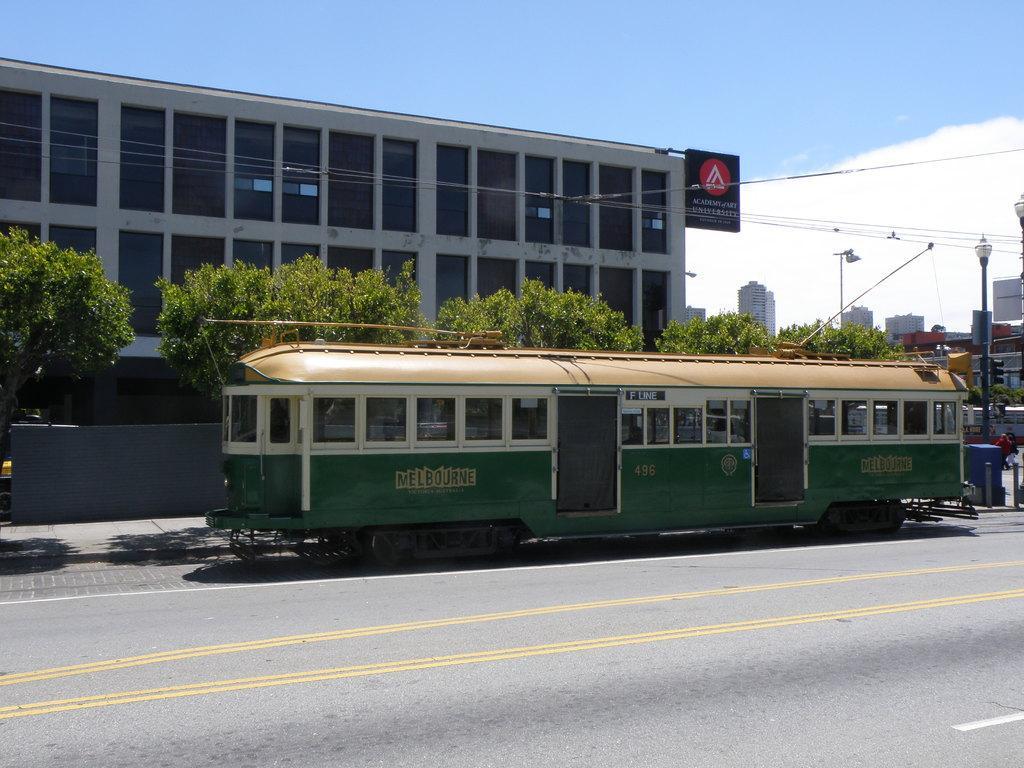Could you give a brief overview of what you see in this image? This is an outside view. Here I can see a green color vehicle on the road. At the back of it there are some trees and a building. On the right side, I can see some poles and few people are walking on the road. In the background there are some buildings. On the top of the image I can see the sky. 